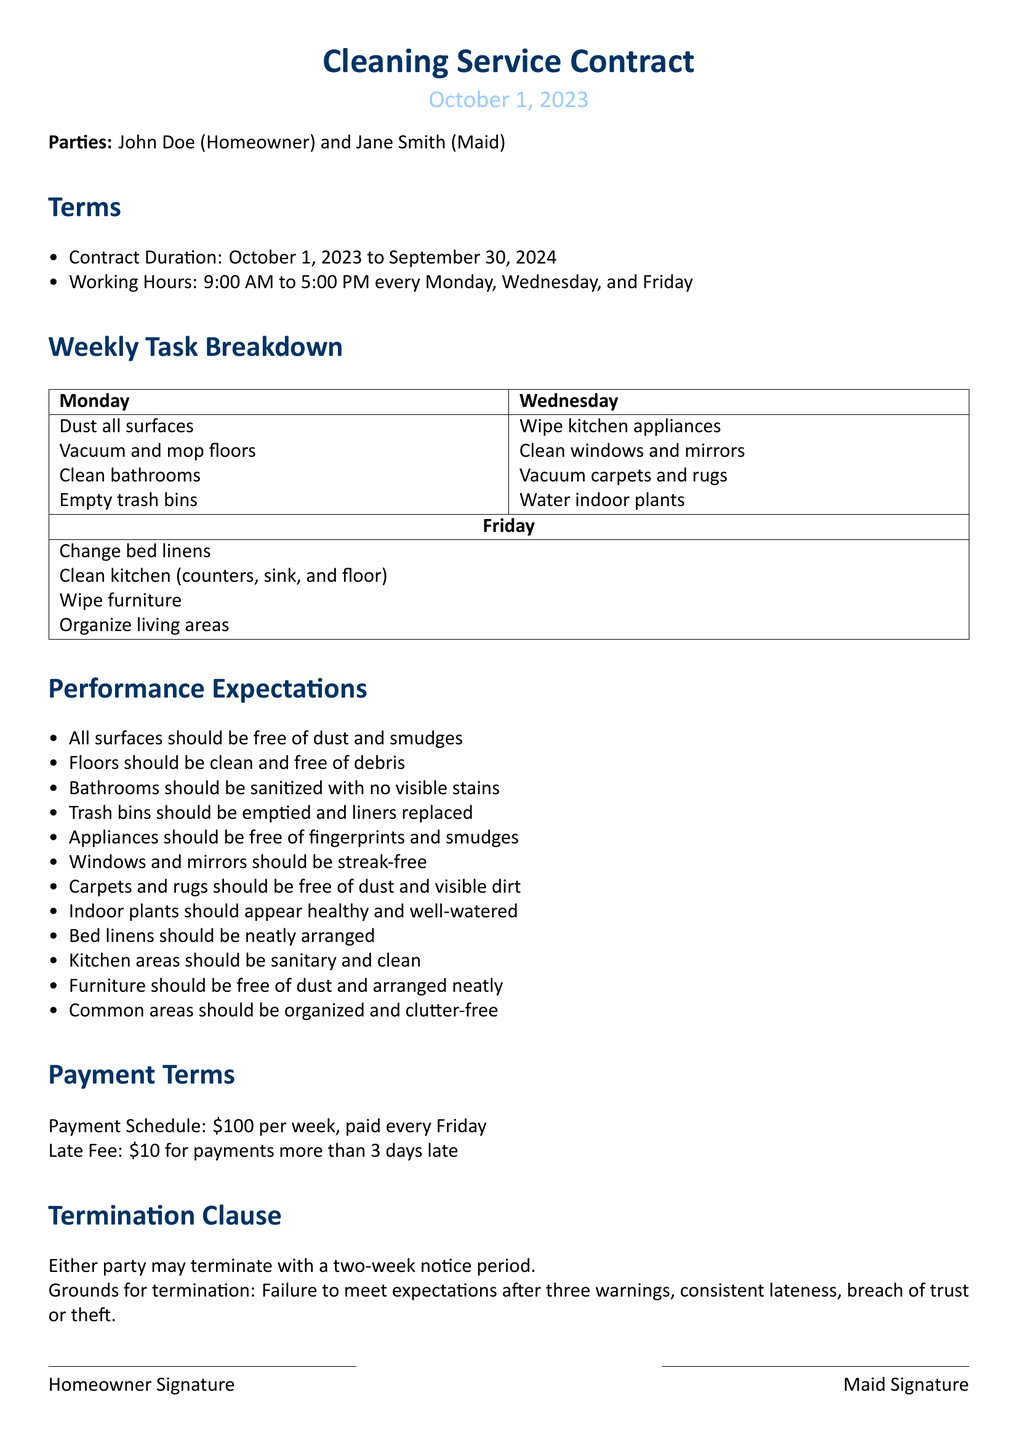What is the contract duration? The contract duration is specified in the document as the period from October 1, 2023, to September 30, 2024.
Answer: October 1, 2023 to September 30, 2024 What are the working hours? The working hours are clearly outlined in the document as from 9:00 AM to 5:00 PM on specified days of the week.
Answer: 9:00 AM to 5:00 PM What is the weekly payment amount? The weekly payment amount is stated directly in the payment terms of the contract.
Answer: $100 What tasks are performed on Wednesdays? The document lists specific cleaning tasks assigned for Wednesdays, making it possible to extract this information.
Answer: Wipe kitchen appliances, Clean windows and mirrors, Vacuum carpets and rugs, Water indoor plants What must be true for the bathrooms? The document details performance expectations, describing how the bathrooms should be maintained.
Answer: Bathrooms should be sanitized with no visible stains How many warnings are needed for termination due to failure to meet expectations? The termination clause specifies a process that requires multiple warnings before action can be taken.
Answer: Three warnings What is the late fee for delayed payments? The document includes the financial consequences for not adhering to the payment schedule, stating a specific amount.
Answer: $10 What is one ground for termination? The contract outlines specific conditions under which termination may occur, providing this information directly.
Answer: Failure to meet expectations after three warnings What is the last day of the contract? The end date of the contract is provided in the terms section and can be easily identified as such.
Answer: September 30, 2024 